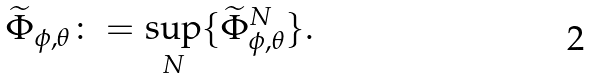Convert formula to latex. <formula><loc_0><loc_0><loc_500><loc_500>\widetilde { \Phi } _ { \phi , \theta } \colon = \sup _ { N } \{ { \widetilde { \Phi } } _ { \phi , \theta } ^ { N } \} .</formula> 